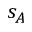<formula> <loc_0><loc_0><loc_500><loc_500>s _ { A }</formula> 